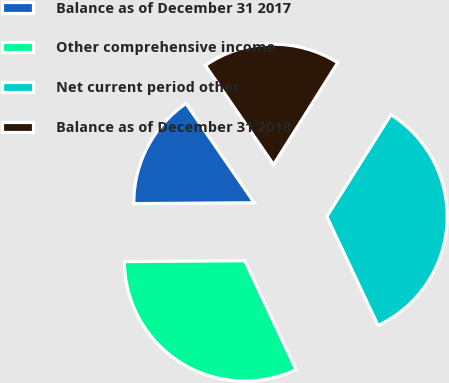Convert chart to OTSL. <chart><loc_0><loc_0><loc_500><loc_500><pie_chart><fcel>Balance as of December 31 2017<fcel>Other comprehensive income<fcel>Net current period other<fcel>Balance as of December 31 2018<nl><fcel>15.53%<fcel>31.88%<fcel>34.06%<fcel>18.53%<nl></chart> 